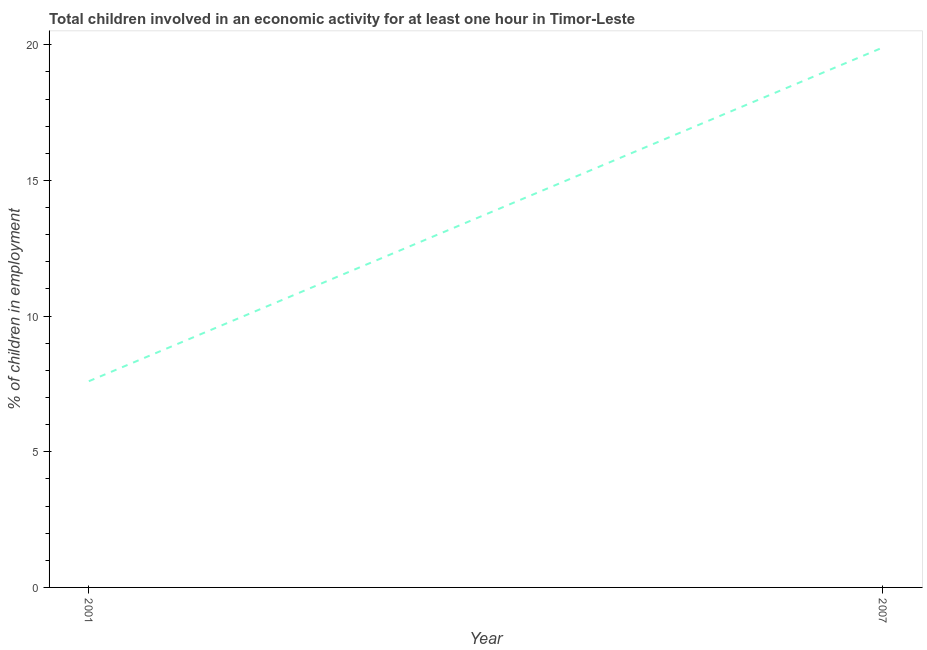What is the percentage of children in employment in 2007?
Provide a succinct answer. 19.9. Across all years, what is the maximum percentage of children in employment?
Provide a short and direct response. 19.9. Across all years, what is the minimum percentage of children in employment?
Your answer should be very brief. 7.6. In which year was the percentage of children in employment maximum?
Your response must be concise. 2007. In which year was the percentage of children in employment minimum?
Your answer should be compact. 2001. What is the difference between the percentage of children in employment in 2001 and 2007?
Provide a succinct answer. -12.3. What is the average percentage of children in employment per year?
Your response must be concise. 13.75. What is the median percentage of children in employment?
Keep it short and to the point. 13.75. Do a majority of the years between 2001 and 2007 (inclusive) have percentage of children in employment greater than 14 %?
Provide a short and direct response. No. What is the ratio of the percentage of children in employment in 2001 to that in 2007?
Your answer should be very brief. 0.38. How many years are there in the graph?
Offer a terse response. 2. Does the graph contain grids?
Make the answer very short. No. What is the title of the graph?
Your answer should be very brief. Total children involved in an economic activity for at least one hour in Timor-Leste. What is the label or title of the X-axis?
Offer a terse response. Year. What is the label or title of the Y-axis?
Provide a succinct answer. % of children in employment. What is the % of children in employment in 2001?
Your answer should be compact. 7.6. What is the % of children in employment in 2007?
Ensure brevity in your answer.  19.9. What is the difference between the % of children in employment in 2001 and 2007?
Provide a succinct answer. -12.3. What is the ratio of the % of children in employment in 2001 to that in 2007?
Your answer should be compact. 0.38. 